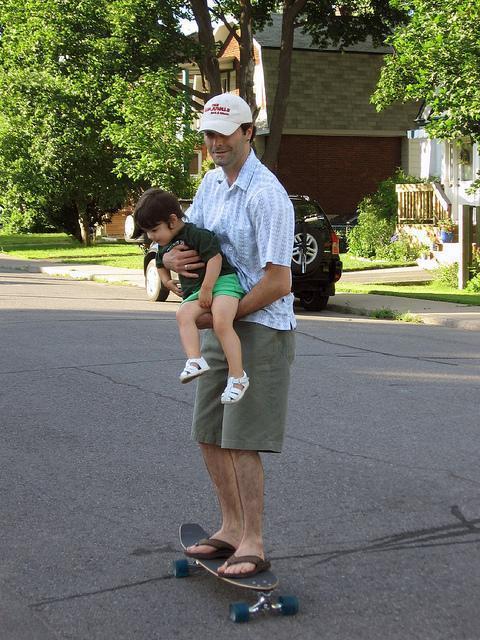How many wheels of the skateboard are touching the ground?
Give a very brief answer. 4. How many people can you see?
Give a very brief answer. 2. 